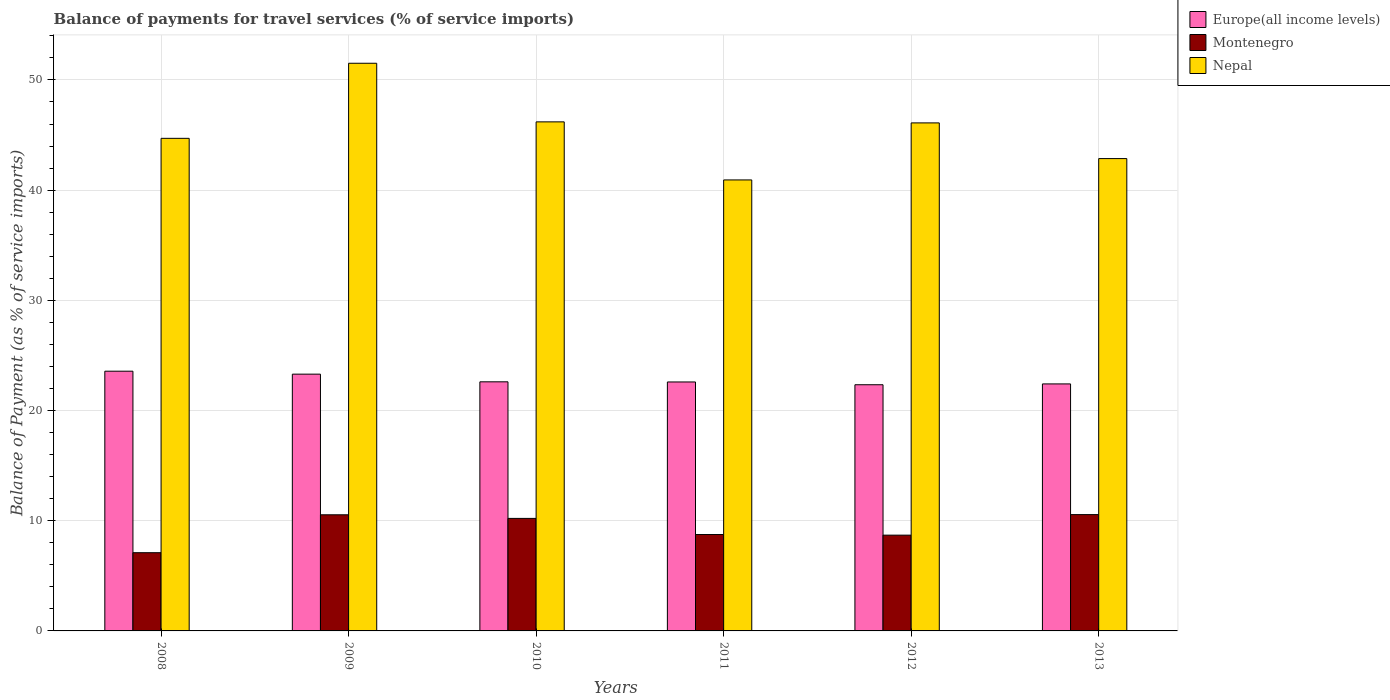Are the number of bars on each tick of the X-axis equal?
Make the answer very short. Yes. What is the label of the 2nd group of bars from the left?
Offer a very short reply. 2009. In how many cases, is the number of bars for a given year not equal to the number of legend labels?
Your answer should be very brief. 0. What is the balance of payments for travel services in Nepal in 2009?
Your response must be concise. 51.51. Across all years, what is the maximum balance of payments for travel services in Montenegro?
Offer a terse response. 10.56. Across all years, what is the minimum balance of payments for travel services in Montenegro?
Give a very brief answer. 7.1. In which year was the balance of payments for travel services in Europe(all income levels) maximum?
Provide a short and direct response. 2008. In which year was the balance of payments for travel services in Montenegro minimum?
Keep it short and to the point. 2008. What is the total balance of payments for travel services in Nepal in the graph?
Your answer should be very brief. 272.29. What is the difference between the balance of payments for travel services in Europe(all income levels) in 2009 and that in 2013?
Offer a terse response. 0.89. What is the difference between the balance of payments for travel services in Europe(all income levels) in 2011 and the balance of payments for travel services in Nepal in 2012?
Your answer should be compact. -23.51. What is the average balance of payments for travel services in Europe(all income levels) per year?
Make the answer very short. 22.8. In the year 2010, what is the difference between the balance of payments for travel services in Montenegro and balance of payments for travel services in Nepal?
Keep it short and to the point. -35.98. What is the ratio of the balance of payments for travel services in Nepal in 2008 to that in 2011?
Offer a very short reply. 1.09. Is the balance of payments for travel services in Montenegro in 2009 less than that in 2012?
Provide a succinct answer. No. Is the difference between the balance of payments for travel services in Montenegro in 2010 and 2012 greater than the difference between the balance of payments for travel services in Nepal in 2010 and 2012?
Give a very brief answer. Yes. What is the difference between the highest and the second highest balance of payments for travel services in Montenegro?
Provide a succinct answer. 0.02. What is the difference between the highest and the lowest balance of payments for travel services in Europe(all income levels)?
Keep it short and to the point. 1.23. In how many years, is the balance of payments for travel services in Nepal greater than the average balance of payments for travel services in Nepal taken over all years?
Your response must be concise. 3. What does the 3rd bar from the left in 2008 represents?
Provide a short and direct response. Nepal. What does the 2nd bar from the right in 2010 represents?
Ensure brevity in your answer.  Montenegro. How many bars are there?
Your response must be concise. 18. Are all the bars in the graph horizontal?
Your answer should be compact. No. How many years are there in the graph?
Give a very brief answer. 6. What is the difference between two consecutive major ticks on the Y-axis?
Ensure brevity in your answer.  10. Does the graph contain any zero values?
Offer a very short reply. No. How are the legend labels stacked?
Make the answer very short. Vertical. What is the title of the graph?
Ensure brevity in your answer.  Balance of payments for travel services (% of service imports). Does "Northern Mariana Islands" appear as one of the legend labels in the graph?
Offer a very short reply. No. What is the label or title of the X-axis?
Your answer should be compact. Years. What is the label or title of the Y-axis?
Your answer should be compact. Balance of Payment (as % of service imports). What is the Balance of Payment (as % of service imports) of Europe(all income levels) in 2008?
Ensure brevity in your answer.  23.57. What is the Balance of Payment (as % of service imports) in Montenegro in 2008?
Provide a succinct answer. 7.1. What is the Balance of Payment (as % of service imports) in Nepal in 2008?
Give a very brief answer. 44.7. What is the Balance of Payment (as % of service imports) of Europe(all income levels) in 2009?
Offer a very short reply. 23.3. What is the Balance of Payment (as % of service imports) of Montenegro in 2009?
Provide a short and direct response. 10.54. What is the Balance of Payment (as % of service imports) of Nepal in 2009?
Provide a succinct answer. 51.51. What is the Balance of Payment (as % of service imports) in Europe(all income levels) in 2010?
Your answer should be very brief. 22.6. What is the Balance of Payment (as % of service imports) in Montenegro in 2010?
Provide a succinct answer. 10.21. What is the Balance of Payment (as % of service imports) of Nepal in 2010?
Offer a very short reply. 46.19. What is the Balance of Payment (as % of service imports) of Europe(all income levels) in 2011?
Provide a succinct answer. 22.59. What is the Balance of Payment (as % of service imports) in Montenegro in 2011?
Offer a terse response. 8.75. What is the Balance of Payment (as % of service imports) of Nepal in 2011?
Your answer should be compact. 40.93. What is the Balance of Payment (as % of service imports) of Europe(all income levels) in 2012?
Your answer should be compact. 22.34. What is the Balance of Payment (as % of service imports) of Montenegro in 2012?
Provide a succinct answer. 8.69. What is the Balance of Payment (as % of service imports) of Nepal in 2012?
Your answer should be very brief. 46.1. What is the Balance of Payment (as % of service imports) of Europe(all income levels) in 2013?
Make the answer very short. 22.42. What is the Balance of Payment (as % of service imports) of Montenegro in 2013?
Your answer should be compact. 10.56. What is the Balance of Payment (as % of service imports) of Nepal in 2013?
Provide a short and direct response. 42.86. Across all years, what is the maximum Balance of Payment (as % of service imports) in Europe(all income levels)?
Your answer should be compact. 23.57. Across all years, what is the maximum Balance of Payment (as % of service imports) of Montenegro?
Your answer should be very brief. 10.56. Across all years, what is the maximum Balance of Payment (as % of service imports) in Nepal?
Provide a short and direct response. 51.51. Across all years, what is the minimum Balance of Payment (as % of service imports) in Europe(all income levels)?
Provide a succinct answer. 22.34. Across all years, what is the minimum Balance of Payment (as % of service imports) of Montenegro?
Make the answer very short. 7.1. Across all years, what is the minimum Balance of Payment (as % of service imports) of Nepal?
Keep it short and to the point. 40.93. What is the total Balance of Payment (as % of service imports) of Europe(all income levels) in the graph?
Make the answer very short. 136.82. What is the total Balance of Payment (as % of service imports) of Montenegro in the graph?
Provide a short and direct response. 55.84. What is the total Balance of Payment (as % of service imports) in Nepal in the graph?
Make the answer very short. 272.29. What is the difference between the Balance of Payment (as % of service imports) of Europe(all income levels) in 2008 and that in 2009?
Keep it short and to the point. 0.27. What is the difference between the Balance of Payment (as % of service imports) in Montenegro in 2008 and that in 2009?
Your response must be concise. -3.44. What is the difference between the Balance of Payment (as % of service imports) of Nepal in 2008 and that in 2009?
Offer a very short reply. -6.81. What is the difference between the Balance of Payment (as % of service imports) in Europe(all income levels) in 2008 and that in 2010?
Provide a succinct answer. 0.96. What is the difference between the Balance of Payment (as % of service imports) in Montenegro in 2008 and that in 2010?
Keep it short and to the point. -3.11. What is the difference between the Balance of Payment (as % of service imports) in Nepal in 2008 and that in 2010?
Offer a very short reply. -1.49. What is the difference between the Balance of Payment (as % of service imports) of Europe(all income levels) in 2008 and that in 2011?
Your answer should be very brief. 0.98. What is the difference between the Balance of Payment (as % of service imports) of Montenegro in 2008 and that in 2011?
Provide a succinct answer. -1.65. What is the difference between the Balance of Payment (as % of service imports) in Nepal in 2008 and that in 2011?
Keep it short and to the point. 3.77. What is the difference between the Balance of Payment (as % of service imports) in Europe(all income levels) in 2008 and that in 2012?
Provide a short and direct response. 1.23. What is the difference between the Balance of Payment (as % of service imports) in Montenegro in 2008 and that in 2012?
Provide a short and direct response. -1.59. What is the difference between the Balance of Payment (as % of service imports) in Nepal in 2008 and that in 2012?
Your answer should be very brief. -1.4. What is the difference between the Balance of Payment (as % of service imports) of Europe(all income levels) in 2008 and that in 2013?
Offer a very short reply. 1.15. What is the difference between the Balance of Payment (as % of service imports) in Montenegro in 2008 and that in 2013?
Ensure brevity in your answer.  -3.46. What is the difference between the Balance of Payment (as % of service imports) of Nepal in 2008 and that in 2013?
Offer a very short reply. 1.84. What is the difference between the Balance of Payment (as % of service imports) of Europe(all income levels) in 2009 and that in 2010?
Offer a very short reply. 0.7. What is the difference between the Balance of Payment (as % of service imports) of Montenegro in 2009 and that in 2010?
Provide a succinct answer. 0.33. What is the difference between the Balance of Payment (as % of service imports) of Nepal in 2009 and that in 2010?
Provide a succinct answer. 5.32. What is the difference between the Balance of Payment (as % of service imports) in Europe(all income levels) in 2009 and that in 2011?
Provide a short and direct response. 0.71. What is the difference between the Balance of Payment (as % of service imports) of Montenegro in 2009 and that in 2011?
Ensure brevity in your answer.  1.79. What is the difference between the Balance of Payment (as % of service imports) in Nepal in 2009 and that in 2011?
Your response must be concise. 10.59. What is the difference between the Balance of Payment (as % of service imports) of Europe(all income levels) in 2009 and that in 2012?
Offer a terse response. 0.96. What is the difference between the Balance of Payment (as % of service imports) of Montenegro in 2009 and that in 2012?
Offer a very short reply. 1.85. What is the difference between the Balance of Payment (as % of service imports) of Nepal in 2009 and that in 2012?
Give a very brief answer. 5.41. What is the difference between the Balance of Payment (as % of service imports) of Europe(all income levels) in 2009 and that in 2013?
Make the answer very short. 0.89. What is the difference between the Balance of Payment (as % of service imports) of Montenegro in 2009 and that in 2013?
Your response must be concise. -0.02. What is the difference between the Balance of Payment (as % of service imports) in Nepal in 2009 and that in 2013?
Offer a very short reply. 8.65. What is the difference between the Balance of Payment (as % of service imports) in Europe(all income levels) in 2010 and that in 2011?
Ensure brevity in your answer.  0.01. What is the difference between the Balance of Payment (as % of service imports) in Montenegro in 2010 and that in 2011?
Provide a succinct answer. 1.46. What is the difference between the Balance of Payment (as % of service imports) of Nepal in 2010 and that in 2011?
Give a very brief answer. 5.27. What is the difference between the Balance of Payment (as % of service imports) in Europe(all income levels) in 2010 and that in 2012?
Your response must be concise. 0.26. What is the difference between the Balance of Payment (as % of service imports) in Montenegro in 2010 and that in 2012?
Your response must be concise. 1.52. What is the difference between the Balance of Payment (as % of service imports) in Nepal in 2010 and that in 2012?
Keep it short and to the point. 0.09. What is the difference between the Balance of Payment (as % of service imports) in Europe(all income levels) in 2010 and that in 2013?
Keep it short and to the point. 0.19. What is the difference between the Balance of Payment (as % of service imports) of Montenegro in 2010 and that in 2013?
Ensure brevity in your answer.  -0.34. What is the difference between the Balance of Payment (as % of service imports) in Nepal in 2010 and that in 2013?
Make the answer very short. 3.33. What is the difference between the Balance of Payment (as % of service imports) of Europe(all income levels) in 2011 and that in 2012?
Provide a short and direct response. 0.25. What is the difference between the Balance of Payment (as % of service imports) of Montenegro in 2011 and that in 2012?
Your response must be concise. 0.06. What is the difference between the Balance of Payment (as % of service imports) in Nepal in 2011 and that in 2012?
Your answer should be very brief. -5.17. What is the difference between the Balance of Payment (as % of service imports) in Europe(all income levels) in 2011 and that in 2013?
Offer a very short reply. 0.18. What is the difference between the Balance of Payment (as % of service imports) of Montenegro in 2011 and that in 2013?
Your answer should be very brief. -1.81. What is the difference between the Balance of Payment (as % of service imports) of Nepal in 2011 and that in 2013?
Your response must be concise. -1.94. What is the difference between the Balance of Payment (as % of service imports) in Europe(all income levels) in 2012 and that in 2013?
Your answer should be compact. -0.08. What is the difference between the Balance of Payment (as % of service imports) of Montenegro in 2012 and that in 2013?
Give a very brief answer. -1.86. What is the difference between the Balance of Payment (as % of service imports) of Nepal in 2012 and that in 2013?
Keep it short and to the point. 3.24. What is the difference between the Balance of Payment (as % of service imports) of Europe(all income levels) in 2008 and the Balance of Payment (as % of service imports) of Montenegro in 2009?
Offer a terse response. 13.03. What is the difference between the Balance of Payment (as % of service imports) of Europe(all income levels) in 2008 and the Balance of Payment (as % of service imports) of Nepal in 2009?
Your answer should be very brief. -27.94. What is the difference between the Balance of Payment (as % of service imports) in Montenegro in 2008 and the Balance of Payment (as % of service imports) in Nepal in 2009?
Offer a terse response. -44.41. What is the difference between the Balance of Payment (as % of service imports) in Europe(all income levels) in 2008 and the Balance of Payment (as % of service imports) in Montenegro in 2010?
Provide a succinct answer. 13.36. What is the difference between the Balance of Payment (as % of service imports) of Europe(all income levels) in 2008 and the Balance of Payment (as % of service imports) of Nepal in 2010?
Ensure brevity in your answer.  -22.62. What is the difference between the Balance of Payment (as % of service imports) in Montenegro in 2008 and the Balance of Payment (as % of service imports) in Nepal in 2010?
Offer a terse response. -39.1. What is the difference between the Balance of Payment (as % of service imports) of Europe(all income levels) in 2008 and the Balance of Payment (as % of service imports) of Montenegro in 2011?
Your response must be concise. 14.82. What is the difference between the Balance of Payment (as % of service imports) in Europe(all income levels) in 2008 and the Balance of Payment (as % of service imports) in Nepal in 2011?
Your answer should be very brief. -17.36. What is the difference between the Balance of Payment (as % of service imports) in Montenegro in 2008 and the Balance of Payment (as % of service imports) in Nepal in 2011?
Your answer should be compact. -33.83. What is the difference between the Balance of Payment (as % of service imports) in Europe(all income levels) in 2008 and the Balance of Payment (as % of service imports) in Montenegro in 2012?
Your response must be concise. 14.88. What is the difference between the Balance of Payment (as % of service imports) in Europe(all income levels) in 2008 and the Balance of Payment (as % of service imports) in Nepal in 2012?
Keep it short and to the point. -22.53. What is the difference between the Balance of Payment (as % of service imports) of Montenegro in 2008 and the Balance of Payment (as % of service imports) of Nepal in 2012?
Make the answer very short. -39. What is the difference between the Balance of Payment (as % of service imports) in Europe(all income levels) in 2008 and the Balance of Payment (as % of service imports) in Montenegro in 2013?
Your response must be concise. 13.01. What is the difference between the Balance of Payment (as % of service imports) in Europe(all income levels) in 2008 and the Balance of Payment (as % of service imports) in Nepal in 2013?
Your response must be concise. -19.29. What is the difference between the Balance of Payment (as % of service imports) in Montenegro in 2008 and the Balance of Payment (as % of service imports) in Nepal in 2013?
Offer a terse response. -35.76. What is the difference between the Balance of Payment (as % of service imports) in Europe(all income levels) in 2009 and the Balance of Payment (as % of service imports) in Montenegro in 2010?
Ensure brevity in your answer.  13.09. What is the difference between the Balance of Payment (as % of service imports) in Europe(all income levels) in 2009 and the Balance of Payment (as % of service imports) in Nepal in 2010?
Make the answer very short. -22.89. What is the difference between the Balance of Payment (as % of service imports) in Montenegro in 2009 and the Balance of Payment (as % of service imports) in Nepal in 2010?
Give a very brief answer. -35.66. What is the difference between the Balance of Payment (as % of service imports) of Europe(all income levels) in 2009 and the Balance of Payment (as % of service imports) of Montenegro in 2011?
Ensure brevity in your answer.  14.55. What is the difference between the Balance of Payment (as % of service imports) of Europe(all income levels) in 2009 and the Balance of Payment (as % of service imports) of Nepal in 2011?
Offer a very short reply. -17.62. What is the difference between the Balance of Payment (as % of service imports) in Montenegro in 2009 and the Balance of Payment (as % of service imports) in Nepal in 2011?
Offer a terse response. -30.39. What is the difference between the Balance of Payment (as % of service imports) of Europe(all income levels) in 2009 and the Balance of Payment (as % of service imports) of Montenegro in 2012?
Your response must be concise. 14.61. What is the difference between the Balance of Payment (as % of service imports) of Europe(all income levels) in 2009 and the Balance of Payment (as % of service imports) of Nepal in 2012?
Ensure brevity in your answer.  -22.8. What is the difference between the Balance of Payment (as % of service imports) in Montenegro in 2009 and the Balance of Payment (as % of service imports) in Nepal in 2012?
Provide a short and direct response. -35.56. What is the difference between the Balance of Payment (as % of service imports) in Europe(all income levels) in 2009 and the Balance of Payment (as % of service imports) in Montenegro in 2013?
Your answer should be compact. 12.75. What is the difference between the Balance of Payment (as % of service imports) in Europe(all income levels) in 2009 and the Balance of Payment (as % of service imports) in Nepal in 2013?
Provide a succinct answer. -19.56. What is the difference between the Balance of Payment (as % of service imports) of Montenegro in 2009 and the Balance of Payment (as % of service imports) of Nepal in 2013?
Provide a short and direct response. -32.32. What is the difference between the Balance of Payment (as % of service imports) in Europe(all income levels) in 2010 and the Balance of Payment (as % of service imports) in Montenegro in 2011?
Your answer should be compact. 13.86. What is the difference between the Balance of Payment (as % of service imports) in Europe(all income levels) in 2010 and the Balance of Payment (as % of service imports) in Nepal in 2011?
Provide a short and direct response. -18.32. What is the difference between the Balance of Payment (as % of service imports) of Montenegro in 2010 and the Balance of Payment (as % of service imports) of Nepal in 2011?
Offer a terse response. -30.71. What is the difference between the Balance of Payment (as % of service imports) in Europe(all income levels) in 2010 and the Balance of Payment (as % of service imports) in Montenegro in 2012?
Your answer should be very brief. 13.91. What is the difference between the Balance of Payment (as % of service imports) of Europe(all income levels) in 2010 and the Balance of Payment (as % of service imports) of Nepal in 2012?
Your answer should be very brief. -23.5. What is the difference between the Balance of Payment (as % of service imports) in Montenegro in 2010 and the Balance of Payment (as % of service imports) in Nepal in 2012?
Provide a short and direct response. -35.89. What is the difference between the Balance of Payment (as % of service imports) in Europe(all income levels) in 2010 and the Balance of Payment (as % of service imports) in Montenegro in 2013?
Offer a very short reply. 12.05. What is the difference between the Balance of Payment (as % of service imports) in Europe(all income levels) in 2010 and the Balance of Payment (as % of service imports) in Nepal in 2013?
Give a very brief answer. -20.26. What is the difference between the Balance of Payment (as % of service imports) of Montenegro in 2010 and the Balance of Payment (as % of service imports) of Nepal in 2013?
Offer a terse response. -32.65. What is the difference between the Balance of Payment (as % of service imports) in Europe(all income levels) in 2011 and the Balance of Payment (as % of service imports) in Montenegro in 2012?
Ensure brevity in your answer.  13.9. What is the difference between the Balance of Payment (as % of service imports) of Europe(all income levels) in 2011 and the Balance of Payment (as % of service imports) of Nepal in 2012?
Make the answer very short. -23.51. What is the difference between the Balance of Payment (as % of service imports) of Montenegro in 2011 and the Balance of Payment (as % of service imports) of Nepal in 2012?
Provide a succinct answer. -37.35. What is the difference between the Balance of Payment (as % of service imports) in Europe(all income levels) in 2011 and the Balance of Payment (as % of service imports) in Montenegro in 2013?
Your answer should be very brief. 12.04. What is the difference between the Balance of Payment (as % of service imports) of Europe(all income levels) in 2011 and the Balance of Payment (as % of service imports) of Nepal in 2013?
Provide a succinct answer. -20.27. What is the difference between the Balance of Payment (as % of service imports) in Montenegro in 2011 and the Balance of Payment (as % of service imports) in Nepal in 2013?
Offer a terse response. -34.11. What is the difference between the Balance of Payment (as % of service imports) of Europe(all income levels) in 2012 and the Balance of Payment (as % of service imports) of Montenegro in 2013?
Offer a very short reply. 11.78. What is the difference between the Balance of Payment (as % of service imports) of Europe(all income levels) in 2012 and the Balance of Payment (as % of service imports) of Nepal in 2013?
Your response must be concise. -20.52. What is the difference between the Balance of Payment (as % of service imports) of Montenegro in 2012 and the Balance of Payment (as % of service imports) of Nepal in 2013?
Your response must be concise. -34.17. What is the average Balance of Payment (as % of service imports) in Europe(all income levels) per year?
Offer a very short reply. 22.8. What is the average Balance of Payment (as % of service imports) of Montenegro per year?
Give a very brief answer. 9.31. What is the average Balance of Payment (as % of service imports) of Nepal per year?
Give a very brief answer. 45.38. In the year 2008, what is the difference between the Balance of Payment (as % of service imports) in Europe(all income levels) and Balance of Payment (as % of service imports) in Montenegro?
Give a very brief answer. 16.47. In the year 2008, what is the difference between the Balance of Payment (as % of service imports) in Europe(all income levels) and Balance of Payment (as % of service imports) in Nepal?
Give a very brief answer. -21.13. In the year 2008, what is the difference between the Balance of Payment (as % of service imports) of Montenegro and Balance of Payment (as % of service imports) of Nepal?
Provide a short and direct response. -37.6. In the year 2009, what is the difference between the Balance of Payment (as % of service imports) of Europe(all income levels) and Balance of Payment (as % of service imports) of Montenegro?
Your answer should be compact. 12.76. In the year 2009, what is the difference between the Balance of Payment (as % of service imports) of Europe(all income levels) and Balance of Payment (as % of service imports) of Nepal?
Give a very brief answer. -28.21. In the year 2009, what is the difference between the Balance of Payment (as % of service imports) in Montenegro and Balance of Payment (as % of service imports) in Nepal?
Provide a short and direct response. -40.97. In the year 2010, what is the difference between the Balance of Payment (as % of service imports) in Europe(all income levels) and Balance of Payment (as % of service imports) in Montenegro?
Provide a short and direct response. 12.39. In the year 2010, what is the difference between the Balance of Payment (as % of service imports) in Europe(all income levels) and Balance of Payment (as % of service imports) in Nepal?
Offer a terse response. -23.59. In the year 2010, what is the difference between the Balance of Payment (as % of service imports) in Montenegro and Balance of Payment (as % of service imports) in Nepal?
Keep it short and to the point. -35.98. In the year 2011, what is the difference between the Balance of Payment (as % of service imports) in Europe(all income levels) and Balance of Payment (as % of service imports) in Montenegro?
Provide a succinct answer. 13.84. In the year 2011, what is the difference between the Balance of Payment (as % of service imports) in Europe(all income levels) and Balance of Payment (as % of service imports) in Nepal?
Offer a terse response. -18.33. In the year 2011, what is the difference between the Balance of Payment (as % of service imports) of Montenegro and Balance of Payment (as % of service imports) of Nepal?
Offer a terse response. -32.18. In the year 2012, what is the difference between the Balance of Payment (as % of service imports) in Europe(all income levels) and Balance of Payment (as % of service imports) in Montenegro?
Ensure brevity in your answer.  13.65. In the year 2012, what is the difference between the Balance of Payment (as % of service imports) in Europe(all income levels) and Balance of Payment (as % of service imports) in Nepal?
Ensure brevity in your answer.  -23.76. In the year 2012, what is the difference between the Balance of Payment (as % of service imports) of Montenegro and Balance of Payment (as % of service imports) of Nepal?
Provide a succinct answer. -37.41. In the year 2013, what is the difference between the Balance of Payment (as % of service imports) of Europe(all income levels) and Balance of Payment (as % of service imports) of Montenegro?
Keep it short and to the point. 11.86. In the year 2013, what is the difference between the Balance of Payment (as % of service imports) of Europe(all income levels) and Balance of Payment (as % of service imports) of Nepal?
Give a very brief answer. -20.45. In the year 2013, what is the difference between the Balance of Payment (as % of service imports) of Montenegro and Balance of Payment (as % of service imports) of Nepal?
Offer a very short reply. -32.31. What is the ratio of the Balance of Payment (as % of service imports) in Europe(all income levels) in 2008 to that in 2009?
Your answer should be very brief. 1.01. What is the ratio of the Balance of Payment (as % of service imports) of Montenegro in 2008 to that in 2009?
Offer a very short reply. 0.67. What is the ratio of the Balance of Payment (as % of service imports) of Nepal in 2008 to that in 2009?
Offer a very short reply. 0.87. What is the ratio of the Balance of Payment (as % of service imports) in Europe(all income levels) in 2008 to that in 2010?
Offer a terse response. 1.04. What is the ratio of the Balance of Payment (as % of service imports) in Montenegro in 2008 to that in 2010?
Provide a short and direct response. 0.7. What is the ratio of the Balance of Payment (as % of service imports) in Nepal in 2008 to that in 2010?
Provide a succinct answer. 0.97. What is the ratio of the Balance of Payment (as % of service imports) of Europe(all income levels) in 2008 to that in 2011?
Provide a short and direct response. 1.04. What is the ratio of the Balance of Payment (as % of service imports) of Montenegro in 2008 to that in 2011?
Keep it short and to the point. 0.81. What is the ratio of the Balance of Payment (as % of service imports) of Nepal in 2008 to that in 2011?
Provide a short and direct response. 1.09. What is the ratio of the Balance of Payment (as % of service imports) in Europe(all income levels) in 2008 to that in 2012?
Give a very brief answer. 1.05. What is the ratio of the Balance of Payment (as % of service imports) of Montenegro in 2008 to that in 2012?
Offer a terse response. 0.82. What is the ratio of the Balance of Payment (as % of service imports) in Nepal in 2008 to that in 2012?
Ensure brevity in your answer.  0.97. What is the ratio of the Balance of Payment (as % of service imports) of Europe(all income levels) in 2008 to that in 2013?
Your response must be concise. 1.05. What is the ratio of the Balance of Payment (as % of service imports) of Montenegro in 2008 to that in 2013?
Offer a terse response. 0.67. What is the ratio of the Balance of Payment (as % of service imports) in Nepal in 2008 to that in 2013?
Ensure brevity in your answer.  1.04. What is the ratio of the Balance of Payment (as % of service imports) of Europe(all income levels) in 2009 to that in 2010?
Your response must be concise. 1.03. What is the ratio of the Balance of Payment (as % of service imports) of Montenegro in 2009 to that in 2010?
Your answer should be compact. 1.03. What is the ratio of the Balance of Payment (as % of service imports) of Nepal in 2009 to that in 2010?
Ensure brevity in your answer.  1.12. What is the ratio of the Balance of Payment (as % of service imports) of Europe(all income levels) in 2009 to that in 2011?
Your answer should be compact. 1.03. What is the ratio of the Balance of Payment (as % of service imports) in Montenegro in 2009 to that in 2011?
Your answer should be very brief. 1.2. What is the ratio of the Balance of Payment (as % of service imports) in Nepal in 2009 to that in 2011?
Offer a very short reply. 1.26. What is the ratio of the Balance of Payment (as % of service imports) of Europe(all income levels) in 2009 to that in 2012?
Make the answer very short. 1.04. What is the ratio of the Balance of Payment (as % of service imports) in Montenegro in 2009 to that in 2012?
Your answer should be very brief. 1.21. What is the ratio of the Balance of Payment (as % of service imports) in Nepal in 2009 to that in 2012?
Offer a very short reply. 1.12. What is the ratio of the Balance of Payment (as % of service imports) in Europe(all income levels) in 2009 to that in 2013?
Ensure brevity in your answer.  1.04. What is the ratio of the Balance of Payment (as % of service imports) in Montenegro in 2009 to that in 2013?
Provide a short and direct response. 1. What is the ratio of the Balance of Payment (as % of service imports) of Nepal in 2009 to that in 2013?
Offer a terse response. 1.2. What is the ratio of the Balance of Payment (as % of service imports) of Montenegro in 2010 to that in 2011?
Give a very brief answer. 1.17. What is the ratio of the Balance of Payment (as % of service imports) of Nepal in 2010 to that in 2011?
Give a very brief answer. 1.13. What is the ratio of the Balance of Payment (as % of service imports) of Europe(all income levels) in 2010 to that in 2012?
Your response must be concise. 1.01. What is the ratio of the Balance of Payment (as % of service imports) in Montenegro in 2010 to that in 2012?
Keep it short and to the point. 1.17. What is the ratio of the Balance of Payment (as % of service imports) of Nepal in 2010 to that in 2012?
Your response must be concise. 1. What is the ratio of the Balance of Payment (as % of service imports) of Europe(all income levels) in 2010 to that in 2013?
Your answer should be very brief. 1.01. What is the ratio of the Balance of Payment (as % of service imports) of Montenegro in 2010 to that in 2013?
Offer a very short reply. 0.97. What is the ratio of the Balance of Payment (as % of service imports) of Nepal in 2010 to that in 2013?
Your answer should be compact. 1.08. What is the ratio of the Balance of Payment (as % of service imports) of Europe(all income levels) in 2011 to that in 2012?
Give a very brief answer. 1.01. What is the ratio of the Balance of Payment (as % of service imports) of Nepal in 2011 to that in 2012?
Make the answer very short. 0.89. What is the ratio of the Balance of Payment (as % of service imports) of Europe(all income levels) in 2011 to that in 2013?
Give a very brief answer. 1.01. What is the ratio of the Balance of Payment (as % of service imports) of Montenegro in 2011 to that in 2013?
Ensure brevity in your answer.  0.83. What is the ratio of the Balance of Payment (as % of service imports) of Nepal in 2011 to that in 2013?
Give a very brief answer. 0.95. What is the ratio of the Balance of Payment (as % of service imports) in Europe(all income levels) in 2012 to that in 2013?
Provide a short and direct response. 1. What is the ratio of the Balance of Payment (as % of service imports) of Montenegro in 2012 to that in 2013?
Make the answer very short. 0.82. What is the ratio of the Balance of Payment (as % of service imports) of Nepal in 2012 to that in 2013?
Ensure brevity in your answer.  1.08. What is the difference between the highest and the second highest Balance of Payment (as % of service imports) of Europe(all income levels)?
Give a very brief answer. 0.27. What is the difference between the highest and the second highest Balance of Payment (as % of service imports) of Montenegro?
Make the answer very short. 0.02. What is the difference between the highest and the second highest Balance of Payment (as % of service imports) in Nepal?
Your answer should be very brief. 5.32. What is the difference between the highest and the lowest Balance of Payment (as % of service imports) in Europe(all income levels)?
Make the answer very short. 1.23. What is the difference between the highest and the lowest Balance of Payment (as % of service imports) of Montenegro?
Your answer should be compact. 3.46. What is the difference between the highest and the lowest Balance of Payment (as % of service imports) of Nepal?
Provide a short and direct response. 10.59. 